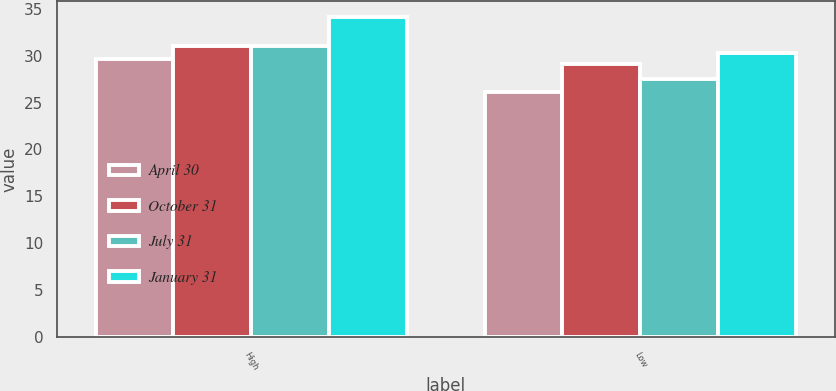Convert chart to OTSL. <chart><loc_0><loc_0><loc_500><loc_500><stacked_bar_chart><ecel><fcel>High<fcel>Low<nl><fcel>April 30<fcel>29.63<fcel>26.1<nl><fcel>October 31<fcel>31.04<fcel>29.06<nl><fcel>July 31<fcel>31.07<fcel>27.49<nl><fcel>January 31<fcel>34.1<fcel>30.29<nl></chart> 